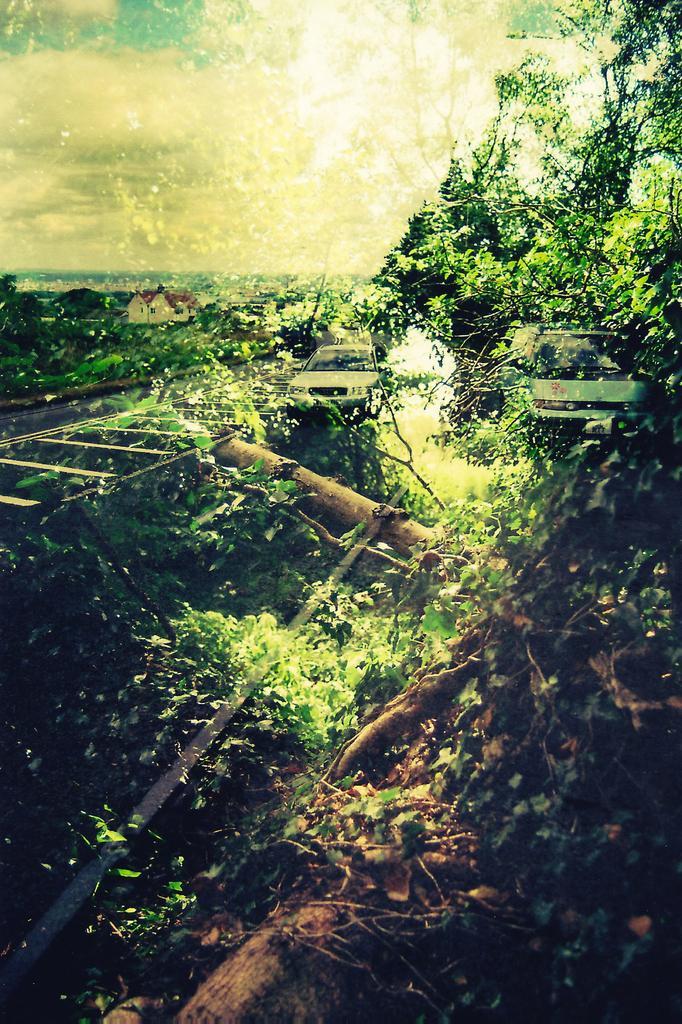Could you give a brief overview of what you see in this image? In this picture I can see there is a picture with reflection of plants, trees and there are two cars, building on the left side and the sky is clear. 